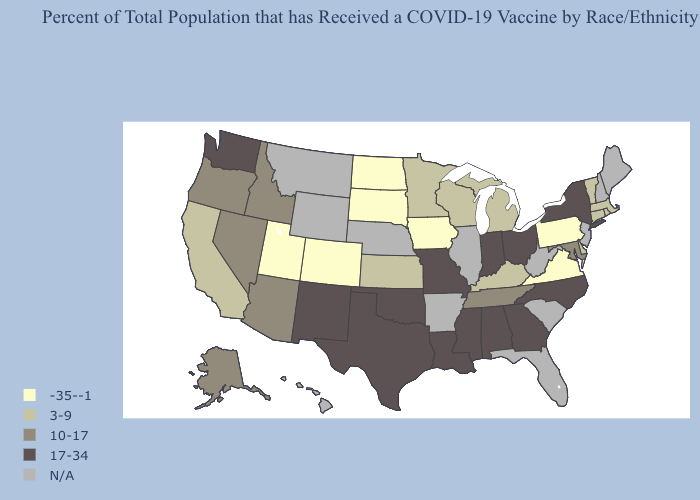What is the lowest value in the USA?
Concise answer only. -35--1. Name the states that have a value in the range N/A?
Concise answer only. Arkansas, Florida, Hawaii, Illinois, Maine, Montana, Nebraska, New Hampshire, New Jersey, South Carolina, West Virginia, Wyoming. Does Virginia have the lowest value in the USA?
Be succinct. Yes. Does Pennsylvania have the lowest value in the USA?
Write a very short answer. Yes. What is the value of Arizona?
Keep it brief. 10-17. Name the states that have a value in the range 3-9?
Write a very short answer. California, Connecticut, Delaware, Kansas, Kentucky, Massachusetts, Michigan, Minnesota, Rhode Island, Vermont, Wisconsin. Does North Dakota have the highest value in the MidWest?
Answer briefly. No. What is the value of Illinois?
Give a very brief answer. N/A. What is the highest value in the USA?
Keep it brief. 17-34. Does Washington have the lowest value in the West?
Answer briefly. No. Is the legend a continuous bar?
Write a very short answer. No. Does Arizona have the highest value in the USA?
Give a very brief answer. No. Does Texas have the highest value in the USA?
Answer briefly. Yes. Name the states that have a value in the range -35--1?
Keep it brief. Colorado, Iowa, North Dakota, Pennsylvania, South Dakota, Utah, Virginia. What is the highest value in the Northeast ?
Quick response, please. 17-34. 